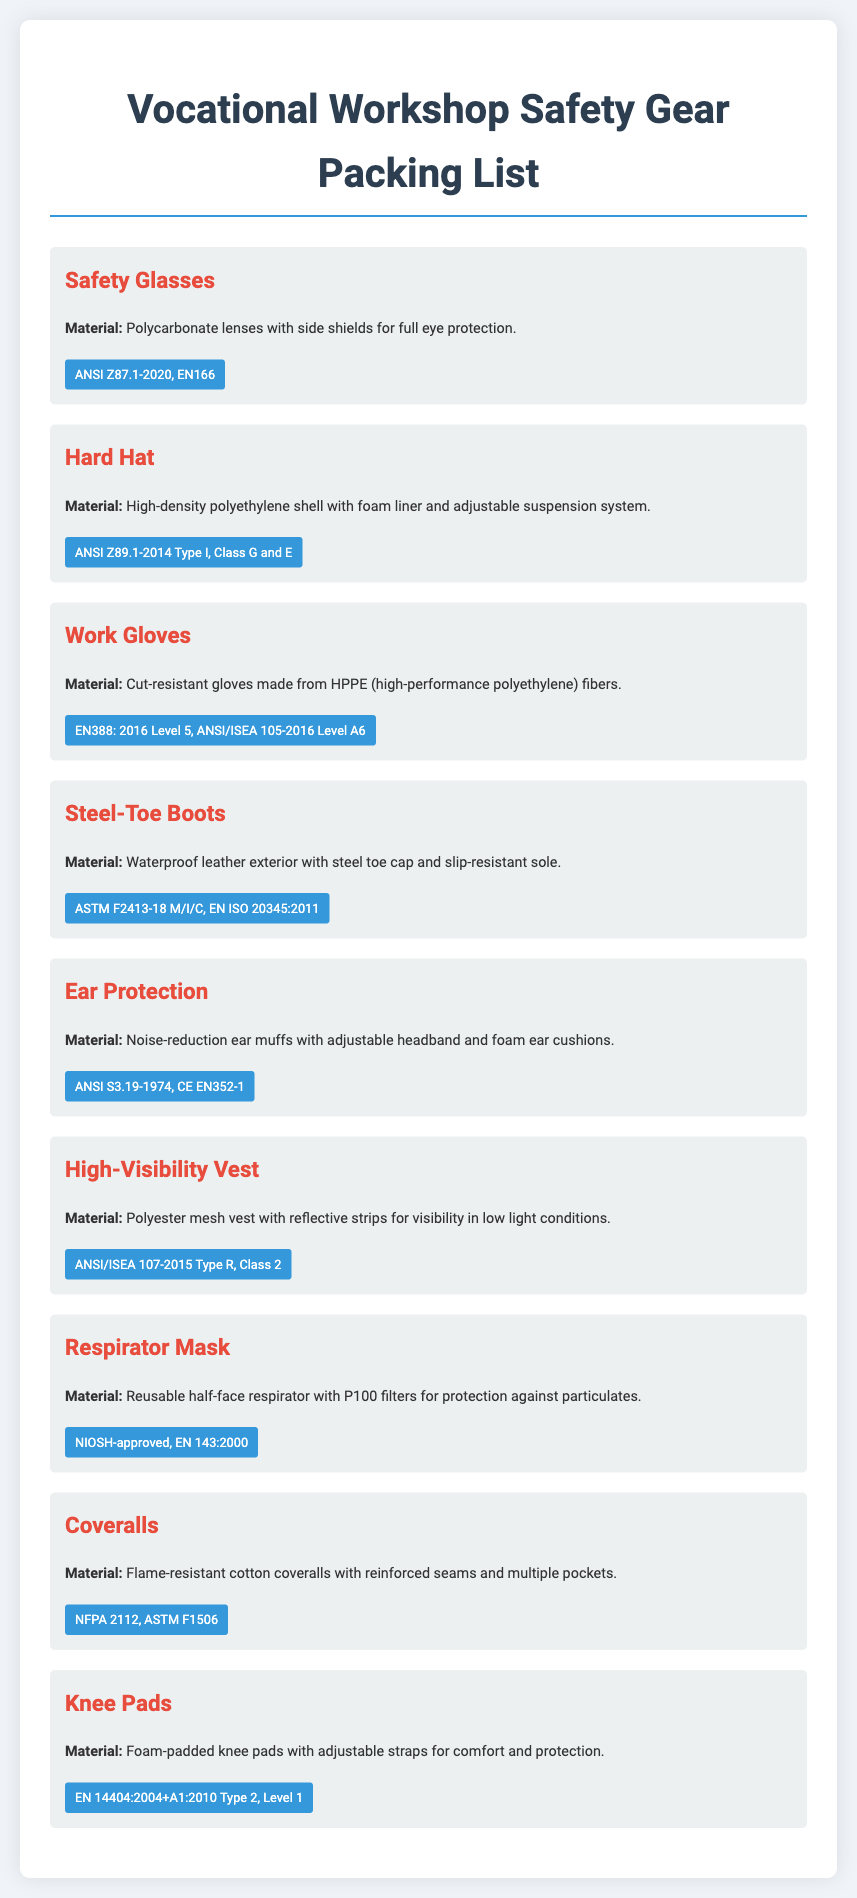What is the material of Safety Glasses? Safety Glasses are made from polycarbonate lenses with side shields for full eye protection.
Answer: Polycarbonate lenses with side shields What certification does the Hard Hat have? The Hard Hat is certified under ANSI Z89.1-2014 Type I, Class G and E.
Answer: ANSI Z89.1-2014 Type I, Class G and E What type of gloves are included in the list? The Packing list includes cut-resistant gloves made from HPPE fibers.
Answer: Cut-resistant gloves made from HPPE fibers How many types of high-visibility vest are specified? The document specifies one type of high-visibility vest which is ANSI/ISEA 107-2015 Type R, Class 2.
Answer: One type What is the function of the respirator mask? The respirator mask provides protection against particulates.
Answer: Protection against particulates What is the material used for Steel-Toe Boots? Steel-Toe Boots are made from waterproof leather with a steel toe cap and slip-resistant sole.
Answer: Waterproof leather exterior with steel toe cap What is the certification level of the knee pads? The Knee Pads are certified to EN 14404:2004+A1:2010 Type 2, Level 1.
Answer: EN 14404:2004+A1:2010 Type 2, Level 1 What type of protection do the ear protection devices offer? The ear protection devices offer noise reduction.
Answer: Noise reduction Why are the coveralls flame-resistant? The coveralls are flame-resistant due to their flame-resistant cotton material.
Answer: Flame-resistant cotton coveralls 